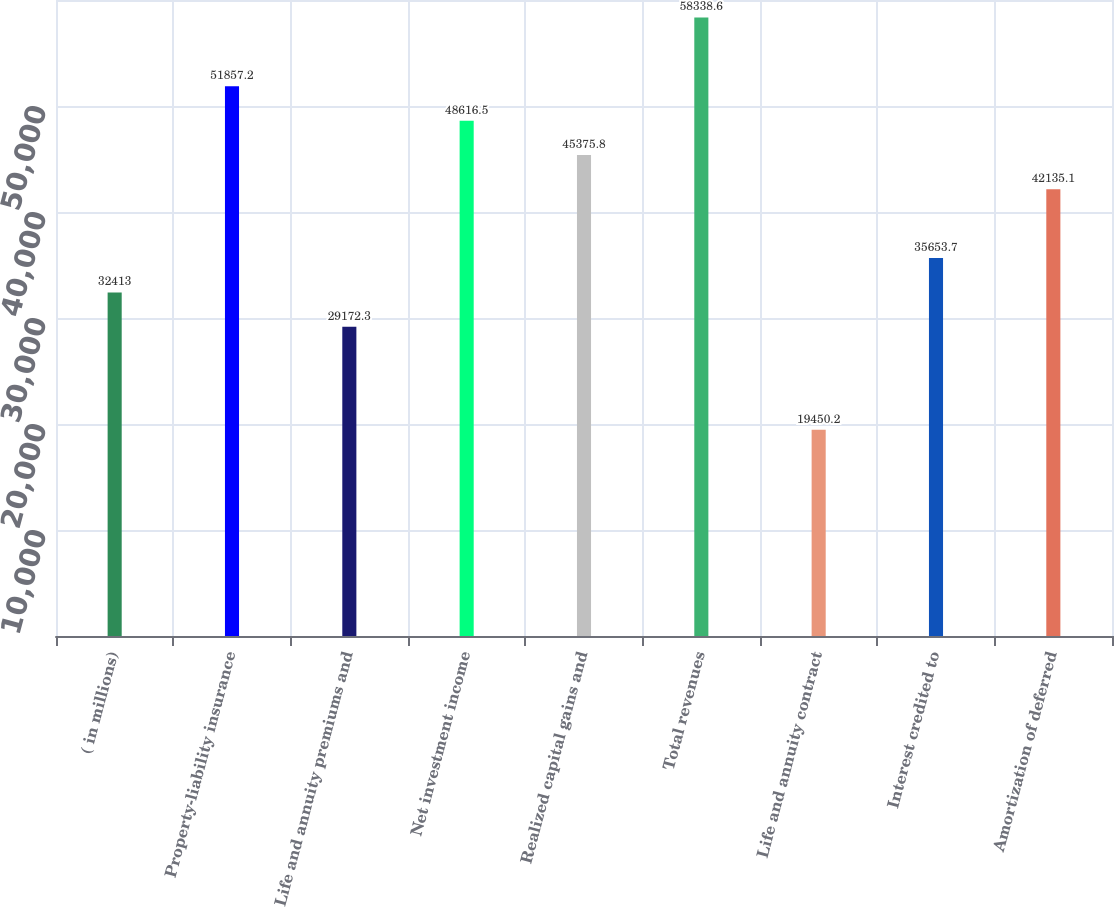<chart> <loc_0><loc_0><loc_500><loc_500><bar_chart><fcel>( in millions)<fcel>Property-liability insurance<fcel>Life and annuity premiums and<fcel>Net investment income<fcel>Realized capital gains and<fcel>Total revenues<fcel>Life and annuity contract<fcel>Interest credited to<fcel>Amortization of deferred<nl><fcel>32413<fcel>51857.2<fcel>29172.3<fcel>48616.5<fcel>45375.8<fcel>58338.6<fcel>19450.2<fcel>35653.7<fcel>42135.1<nl></chart> 